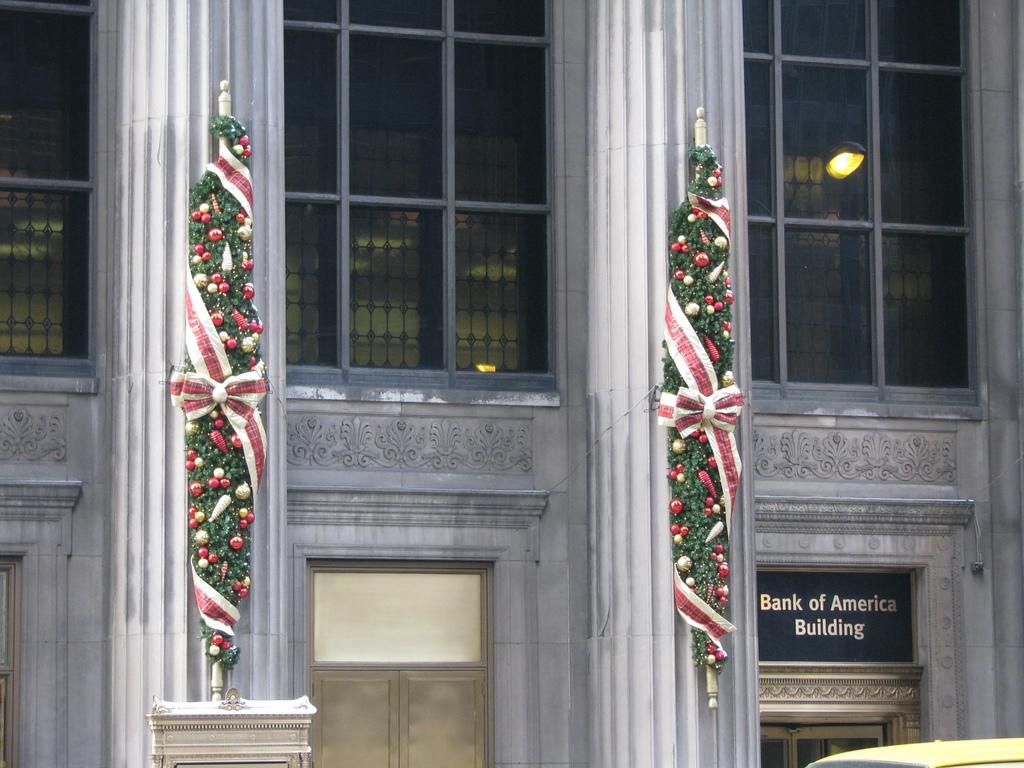What is the main structure visible in the image? There is a building in the image. What architectural features are present in front of the building? There are two pillars in front of the building. How are the pillars decorated? The pillars are decorated. What type of shirt is the power wearing in the image? There is no power or shirt present in the image. What color is the ink used to decorate the pillars in the image? The provided facts do not mention the color of the ink used to decorate the pillars, so it cannot be determined from the image. 